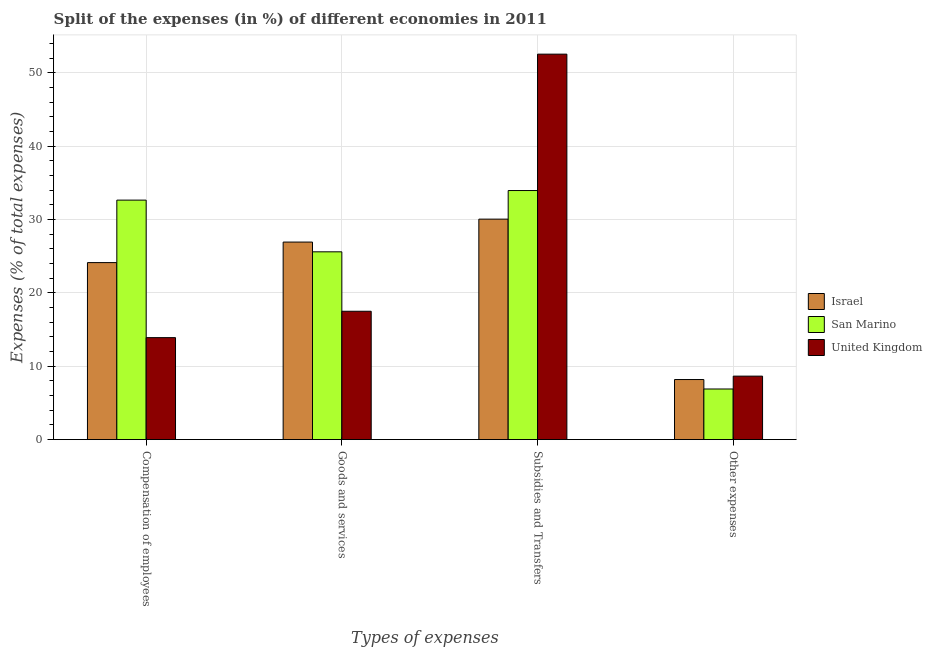How many different coloured bars are there?
Make the answer very short. 3. What is the label of the 4th group of bars from the left?
Your answer should be compact. Other expenses. What is the percentage of amount spent on other expenses in Israel?
Give a very brief answer. 8.19. Across all countries, what is the maximum percentage of amount spent on other expenses?
Offer a terse response. 8.65. Across all countries, what is the minimum percentage of amount spent on subsidies?
Offer a terse response. 30.06. What is the total percentage of amount spent on goods and services in the graph?
Your response must be concise. 70.03. What is the difference between the percentage of amount spent on other expenses in United Kingdom and that in San Marino?
Your response must be concise. 1.75. What is the difference between the percentage of amount spent on compensation of employees in Israel and the percentage of amount spent on other expenses in United Kingdom?
Offer a terse response. 15.48. What is the average percentage of amount spent on goods and services per country?
Give a very brief answer. 23.34. What is the difference between the percentage of amount spent on goods and services and percentage of amount spent on compensation of employees in United Kingdom?
Make the answer very short. 3.6. In how many countries, is the percentage of amount spent on subsidies greater than 14 %?
Your answer should be very brief. 3. What is the ratio of the percentage of amount spent on compensation of employees in Israel to that in San Marino?
Your answer should be very brief. 0.74. Is the percentage of amount spent on other expenses in United Kingdom less than that in Israel?
Offer a terse response. No. Is the difference between the percentage of amount spent on subsidies in Israel and United Kingdom greater than the difference between the percentage of amount spent on compensation of employees in Israel and United Kingdom?
Keep it short and to the point. No. What is the difference between the highest and the second highest percentage of amount spent on goods and services?
Offer a terse response. 1.33. What is the difference between the highest and the lowest percentage of amount spent on subsidies?
Your answer should be very brief. 22.49. Is the sum of the percentage of amount spent on other expenses in United Kingdom and San Marino greater than the maximum percentage of amount spent on goods and services across all countries?
Your answer should be very brief. No. What does the 2nd bar from the left in Subsidies and Transfers represents?
Make the answer very short. San Marino. Are all the bars in the graph horizontal?
Keep it short and to the point. No. What is the difference between two consecutive major ticks on the Y-axis?
Provide a succinct answer. 10. How many legend labels are there?
Make the answer very short. 3. What is the title of the graph?
Make the answer very short. Split of the expenses (in %) of different economies in 2011. Does "Other small states" appear as one of the legend labels in the graph?
Offer a terse response. No. What is the label or title of the X-axis?
Ensure brevity in your answer.  Types of expenses. What is the label or title of the Y-axis?
Provide a short and direct response. Expenses (% of total expenses). What is the Expenses (% of total expenses) of Israel in Compensation of employees?
Provide a short and direct response. 24.13. What is the Expenses (% of total expenses) of San Marino in Compensation of employees?
Provide a succinct answer. 32.65. What is the Expenses (% of total expenses) of United Kingdom in Compensation of employees?
Give a very brief answer. 13.9. What is the Expenses (% of total expenses) of Israel in Goods and services?
Make the answer very short. 26.93. What is the Expenses (% of total expenses) in San Marino in Goods and services?
Make the answer very short. 25.6. What is the Expenses (% of total expenses) of United Kingdom in Goods and services?
Provide a short and direct response. 17.5. What is the Expenses (% of total expenses) of Israel in Subsidies and Transfers?
Ensure brevity in your answer.  30.06. What is the Expenses (% of total expenses) in San Marino in Subsidies and Transfers?
Your answer should be compact. 33.95. What is the Expenses (% of total expenses) in United Kingdom in Subsidies and Transfers?
Provide a short and direct response. 52.55. What is the Expenses (% of total expenses) in Israel in Other expenses?
Your answer should be compact. 8.19. What is the Expenses (% of total expenses) in San Marino in Other expenses?
Your answer should be very brief. 6.9. What is the Expenses (% of total expenses) in United Kingdom in Other expenses?
Make the answer very short. 8.65. Across all Types of expenses, what is the maximum Expenses (% of total expenses) in Israel?
Keep it short and to the point. 30.06. Across all Types of expenses, what is the maximum Expenses (% of total expenses) of San Marino?
Your answer should be very brief. 33.95. Across all Types of expenses, what is the maximum Expenses (% of total expenses) of United Kingdom?
Provide a succinct answer. 52.55. Across all Types of expenses, what is the minimum Expenses (% of total expenses) in Israel?
Ensure brevity in your answer.  8.19. Across all Types of expenses, what is the minimum Expenses (% of total expenses) of San Marino?
Give a very brief answer. 6.9. Across all Types of expenses, what is the minimum Expenses (% of total expenses) of United Kingdom?
Offer a terse response. 8.65. What is the total Expenses (% of total expenses) of Israel in the graph?
Provide a succinct answer. 89.3. What is the total Expenses (% of total expenses) in San Marino in the graph?
Offer a terse response. 99.1. What is the total Expenses (% of total expenses) of United Kingdom in the graph?
Offer a terse response. 92.6. What is the difference between the Expenses (% of total expenses) of Israel in Compensation of employees and that in Goods and services?
Give a very brief answer. -2.8. What is the difference between the Expenses (% of total expenses) of San Marino in Compensation of employees and that in Goods and services?
Offer a very short reply. 7.05. What is the difference between the Expenses (% of total expenses) in United Kingdom in Compensation of employees and that in Goods and services?
Give a very brief answer. -3.6. What is the difference between the Expenses (% of total expenses) of Israel in Compensation of employees and that in Subsidies and Transfers?
Offer a very short reply. -5.92. What is the difference between the Expenses (% of total expenses) in San Marino in Compensation of employees and that in Subsidies and Transfers?
Keep it short and to the point. -1.31. What is the difference between the Expenses (% of total expenses) of United Kingdom in Compensation of employees and that in Subsidies and Transfers?
Ensure brevity in your answer.  -38.65. What is the difference between the Expenses (% of total expenses) in Israel in Compensation of employees and that in Other expenses?
Provide a succinct answer. 15.94. What is the difference between the Expenses (% of total expenses) of San Marino in Compensation of employees and that in Other expenses?
Make the answer very short. 25.75. What is the difference between the Expenses (% of total expenses) of United Kingdom in Compensation of employees and that in Other expenses?
Your answer should be compact. 5.25. What is the difference between the Expenses (% of total expenses) of Israel in Goods and services and that in Subsidies and Transfers?
Give a very brief answer. -3.13. What is the difference between the Expenses (% of total expenses) of San Marino in Goods and services and that in Subsidies and Transfers?
Offer a terse response. -8.35. What is the difference between the Expenses (% of total expenses) of United Kingdom in Goods and services and that in Subsidies and Transfers?
Offer a terse response. -35.05. What is the difference between the Expenses (% of total expenses) of Israel in Goods and services and that in Other expenses?
Your answer should be compact. 18.74. What is the difference between the Expenses (% of total expenses) in San Marino in Goods and services and that in Other expenses?
Offer a terse response. 18.7. What is the difference between the Expenses (% of total expenses) in United Kingdom in Goods and services and that in Other expenses?
Provide a short and direct response. 8.84. What is the difference between the Expenses (% of total expenses) in Israel in Subsidies and Transfers and that in Other expenses?
Give a very brief answer. 21.87. What is the difference between the Expenses (% of total expenses) of San Marino in Subsidies and Transfers and that in Other expenses?
Offer a terse response. 27.05. What is the difference between the Expenses (% of total expenses) in United Kingdom in Subsidies and Transfers and that in Other expenses?
Ensure brevity in your answer.  43.89. What is the difference between the Expenses (% of total expenses) in Israel in Compensation of employees and the Expenses (% of total expenses) in San Marino in Goods and services?
Your answer should be very brief. -1.47. What is the difference between the Expenses (% of total expenses) of Israel in Compensation of employees and the Expenses (% of total expenses) of United Kingdom in Goods and services?
Your answer should be very brief. 6.63. What is the difference between the Expenses (% of total expenses) in San Marino in Compensation of employees and the Expenses (% of total expenses) in United Kingdom in Goods and services?
Your response must be concise. 15.15. What is the difference between the Expenses (% of total expenses) in Israel in Compensation of employees and the Expenses (% of total expenses) in San Marino in Subsidies and Transfers?
Ensure brevity in your answer.  -9.82. What is the difference between the Expenses (% of total expenses) of Israel in Compensation of employees and the Expenses (% of total expenses) of United Kingdom in Subsidies and Transfers?
Ensure brevity in your answer.  -28.42. What is the difference between the Expenses (% of total expenses) of San Marino in Compensation of employees and the Expenses (% of total expenses) of United Kingdom in Subsidies and Transfers?
Keep it short and to the point. -19.9. What is the difference between the Expenses (% of total expenses) in Israel in Compensation of employees and the Expenses (% of total expenses) in San Marino in Other expenses?
Your answer should be compact. 17.23. What is the difference between the Expenses (% of total expenses) of Israel in Compensation of employees and the Expenses (% of total expenses) of United Kingdom in Other expenses?
Provide a short and direct response. 15.48. What is the difference between the Expenses (% of total expenses) in San Marino in Compensation of employees and the Expenses (% of total expenses) in United Kingdom in Other expenses?
Ensure brevity in your answer.  23.99. What is the difference between the Expenses (% of total expenses) in Israel in Goods and services and the Expenses (% of total expenses) in San Marino in Subsidies and Transfers?
Provide a succinct answer. -7.02. What is the difference between the Expenses (% of total expenses) in Israel in Goods and services and the Expenses (% of total expenses) in United Kingdom in Subsidies and Transfers?
Offer a very short reply. -25.62. What is the difference between the Expenses (% of total expenses) of San Marino in Goods and services and the Expenses (% of total expenses) of United Kingdom in Subsidies and Transfers?
Give a very brief answer. -26.95. What is the difference between the Expenses (% of total expenses) in Israel in Goods and services and the Expenses (% of total expenses) in San Marino in Other expenses?
Give a very brief answer. 20.03. What is the difference between the Expenses (% of total expenses) in Israel in Goods and services and the Expenses (% of total expenses) in United Kingdom in Other expenses?
Your response must be concise. 18.28. What is the difference between the Expenses (% of total expenses) of San Marino in Goods and services and the Expenses (% of total expenses) of United Kingdom in Other expenses?
Your answer should be compact. 16.95. What is the difference between the Expenses (% of total expenses) of Israel in Subsidies and Transfers and the Expenses (% of total expenses) of San Marino in Other expenses?
Your answer should be very brief. 23.16. What is the difference between the Expenses (% of total expenses) in Israel in Subsidies and Transfers and the Expenses (% of total expenses) in United Kingdom in Other expenses?
Offer a terse response. 21.4. What is the difference between the Expenses (% of total expenses) of San Marino in Subsidies and Transfers and the Expenses (% of total expenses) of United Kingdom in Other expenses?
Your response must be concise. 25.3. What is the average Expenses (% of total expenses) of Israel per Types of expenses?
Your answer should be very brief. 22.33. What is the average Expenses (% of total expenses) in San Marino per Types of expenses?
Your answer should be very brief. 24.78. What is the average Expenses (% of total expenses) of United Kingdom per Types of expenses?
Your answer should be very brief. 23.15. What is the difference between the Expenses (% of total expenses) of Israel and Expenses (% of total expenses) of San Marino in Compensation of employees?
Your answer should be very brief. -8.52. What is the difference between the Expenses (% of total expenses) in Israel and Expenses (% of total expenses) in United Kingdom in Compensation of employees?
Ensure brevity in your answer.  10.23. What is the difference between the Expenses (% of total expenses) in San Marino and Expenses (% of total expenses) in United Kingdom in Compensation of employees?
Keep it short and to the point. 18.75. What is the difference between the Expenses (% of total expenses) of Israel and Expenses (% of total expenses) of San Marino in Goods and services?
Provide a short and direct response. 1.33. What is the difference between the Expenses (% of total expenses) of Israel and Expenses (% of total expenses) of United Kingdom in Goods and services?
Give a very brief answer. 9.43. What is the difference between the Expenses (% of total expenses) of San Marino and Expenses (% of total expenses) of United Kingdom in Goods and services?
Make the answer very short. 8.1. What is the difference between the Expenses (% of total expenses) in Israel and Expenses (% of total expenses) in San Marino in Subsidies and Transfers?
Your answer should be compact. -3.9. What is the difference between the Expenses (% of total expenses) of Israel and Expenses (% of total expenses) of United Kingdom in Subsidies and Transfers?
Give a very brief answer. -22.49. What is the difference between the Expenses (% of total expenses) of San Marino and Expenses (% of total expenses) of United Kingdom in Subsidies and Transfers?
Provide a succinct answer. -18.59. What is the difference between the Expenses (% of total expenses) of Israel and Expenses (% of total expenses) of San Marino in Other expenses?
Offer a terse response. 1.29. What is the difference between the Expenses (% of total expenses) in Israel and Expenses (% of total expenses) in United Kingdom in Other expenses?
Offer a very short reply. -0.47. What is the difference between the Expenses (% of total expenses) of San Marino and Expenses (% of total expenses) of United Kingdom in Other expenses?
Keep it short and to the point. -1.75. What is the ratio of the Expenses (% of total expenses) in Israel in Compensation of employees to that in Goods and services?
Make the answer very short. 0.9. What is the ratio of the Expenses (% of total expenses) of San Marino in Compensation of employees to that in Goods and services?
Make the answer very short. 1.28. What is the ratio of the Expenses (% of total expenses) of United Kingdom in Compensation of employees to that in Goods and services?
Provide a succinct answer. 0.79. What is the ratio of the Expenses (% of total expenses) of Israel in Compensation of employees to that in Subsidies and Transfers?
Make the answer very short. 0.8. What is the ratio of the Expenses (% of total expenses) of San Marino in Compensation of employees to that in Subsidies and Transfers?
Your response must be concise. 0.96. What is the ratio of the Expenses (% of total expenses) of United Kingdom in Compensation of employees to that in Subsidies and Transfers?
Make the answer very short. 0.26. What is the ratio of the Expenses (% of total expenses) of Israel in Compensation of employees to that in Other expenses?
Make the answer very short. 2.95. What is the ratio of the Expenses (% of total expenses) of San Marino in Compensation of employees to that in Other expenses?
Keep it short and to the point. 4.73. What is the ratio of the Expenses (% of total expenses) of United Kingdom in Compensation of employees to that in Other expenses?
Your answer should be compact. 1.61. What is the ratio of the Expenses (% of total expenses) in Israel in Goods and services to that in Subsidies and Transfers?
Offer a terse response. 0.9. What is the ratio of the Expenses (% of total expenses) in San Marino in Goods and services to that in Subsidies and Transfers?
Your answer should be very brief. 0.75. What is the ratio of the Expenses (% of total expenses) in United Kingdom in Goods and services to that in Subsidies and Transfers?
Offer a very short reply. 0.33. What is the ratio of the Expenses (% of total expenses) in Israel in Goods and services to that in Other expenses?
Keep it short and to the point. 3.29. What is the ratio of the Expenses (% of total expenses) of San Marino in Goods and services to that in Other expenses?
Provide a succinct answer. 3.71. What is the ratio of the Expenses (% of total expenses) in United Kingdom in Goods and services to that in Other expenses?
Your answer should be very brief. 2.02. What is the ratio of the Expenses (% of total expenses) in Israel in Subsidies and Transfers to that in Other expenses?
Ensure brevity in your answer.  3.67. What is the ratio of the Expenses (% of total expenses) in San Marino in Subsidies and Transfers to that in Other expenses?
Provide a succinct answer. 4.92. What is the ratio of the Expenses (% of total expenses) in United Kingdom in Subsidies and Transfers to that in Other expenses?
Keep it short and to the point. 6.07. What is the difference between the highest and the second highest Expenses (% of total expenses) in Israel?
Give a very brief answer. 3.13. What is the difference between the highest and the second highest Expenses (% of total expenses) of San Marino?
Keep it short and to the point. 1.31. What is the difference between the highest and the second highest Expenses (% of total expenses) in United Kingdom?
Provide a succinct answer. 35.05. What is the difference between the highest and the lowest Expenses (% of total expenses) of Israel?
Make the answer very short. 21.87. What is the difference between the highest and the lowest Expenses (% of total expenses) in San Marino?
Your answer should be very brief. 27.05. What is the difference between the highest and the lowest Expenses (% of total expenses) of United Kingdom?
Offer a terse response. 43.89. 